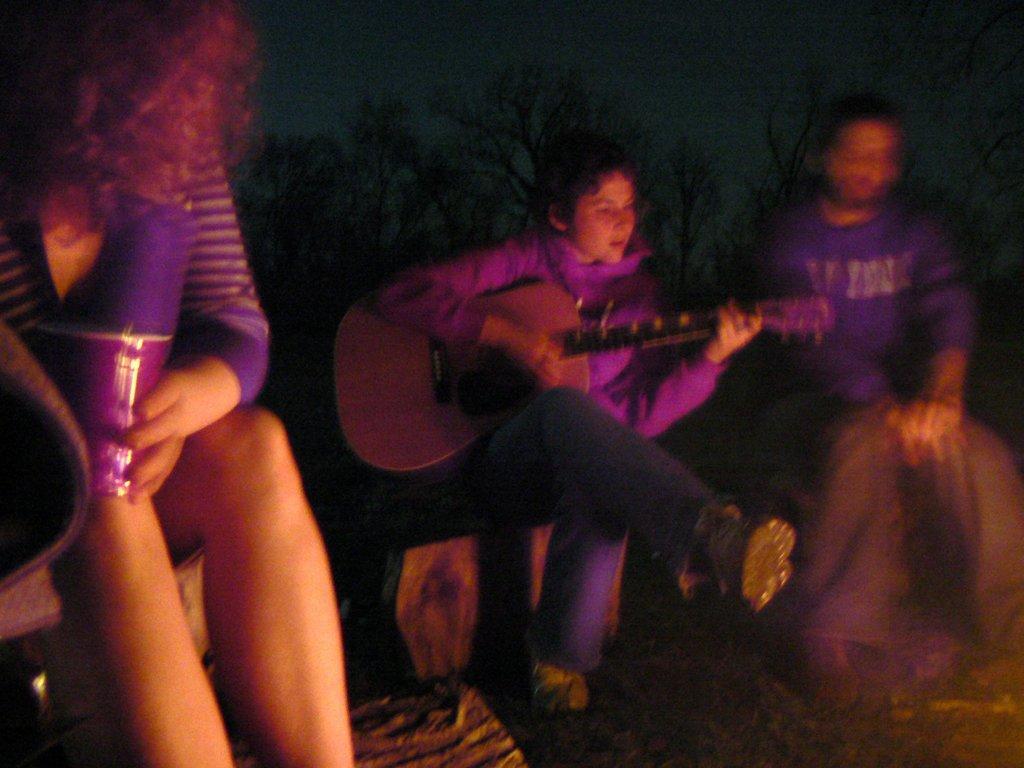Could you give a brief overview of what you see in this image? Here we see three people sitting and the person in the center is a playing guitar and behind them there are trees 